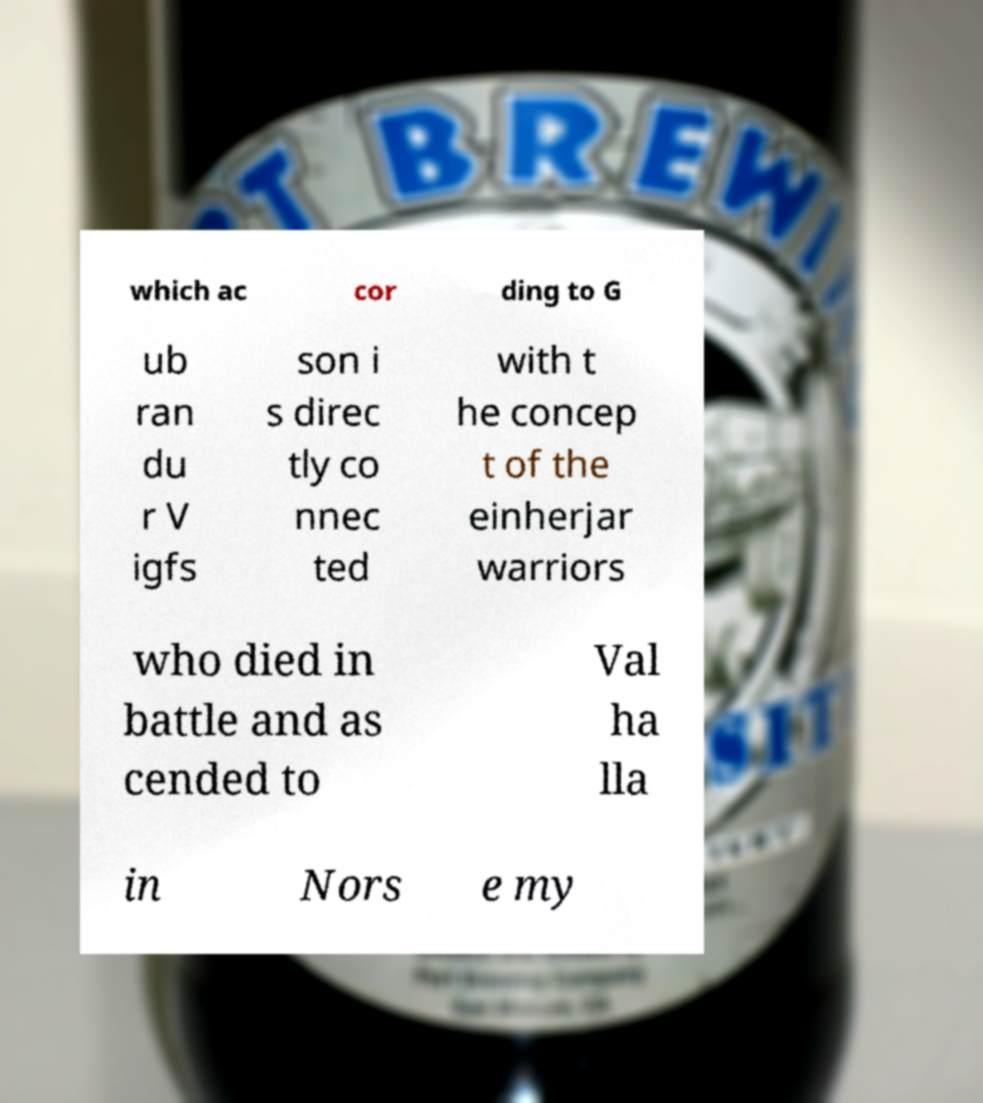I need the written content from this picture converted into text. Can you do that? which ac cor ding to G ub ran du r V igfs son i s direc tly co nnec ted with t he concep t of the einherjar warriors who died in battle and as cended to Val ha lla in Nors e my 